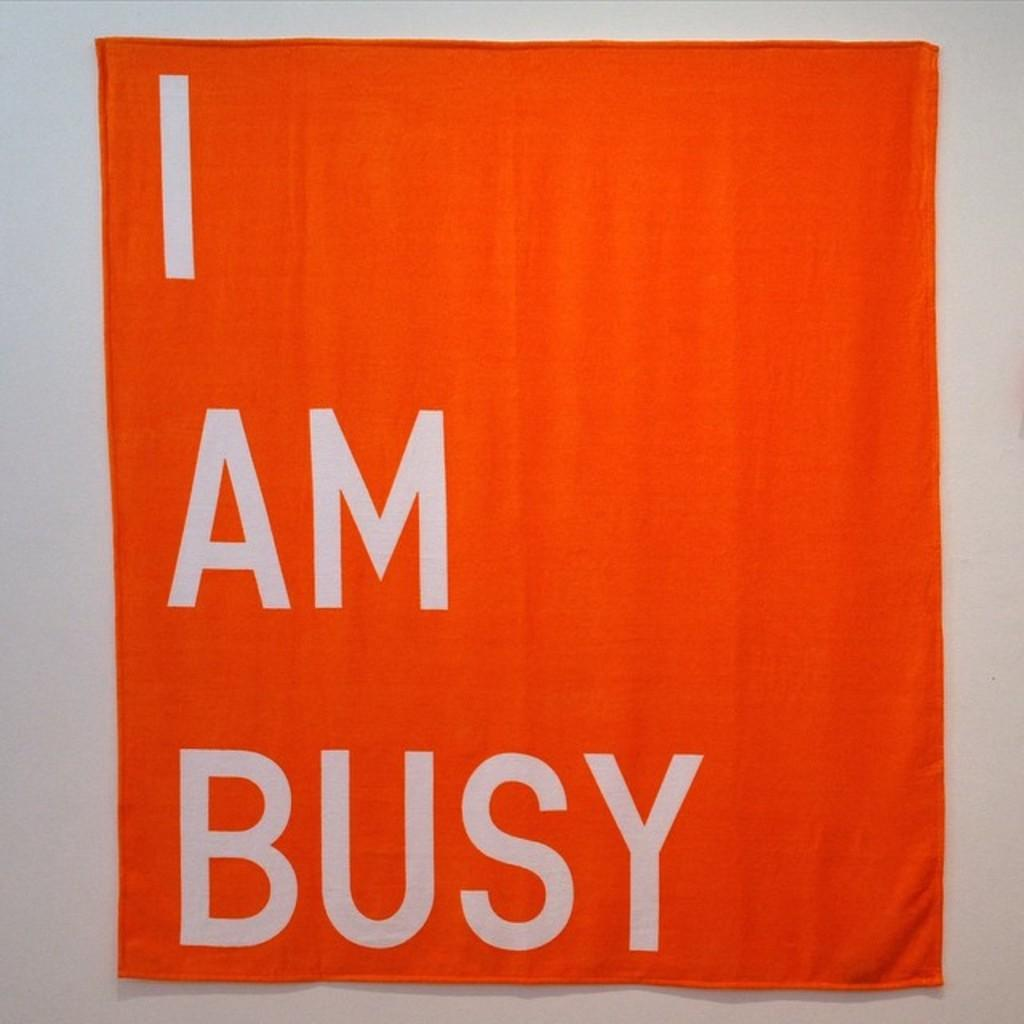<image>
Describe the image concisely. An orange and white sign that says I am Busy on it hangs on a wall 